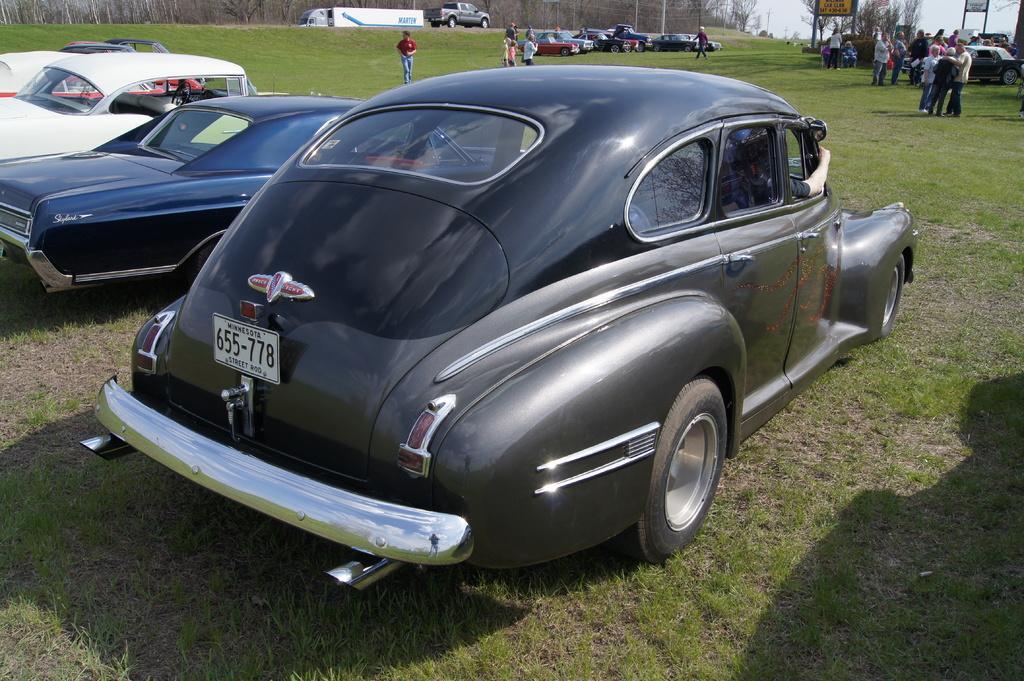Please provide a concise description of this image. In this image there are cars in the ground and people are standing in the ground. 